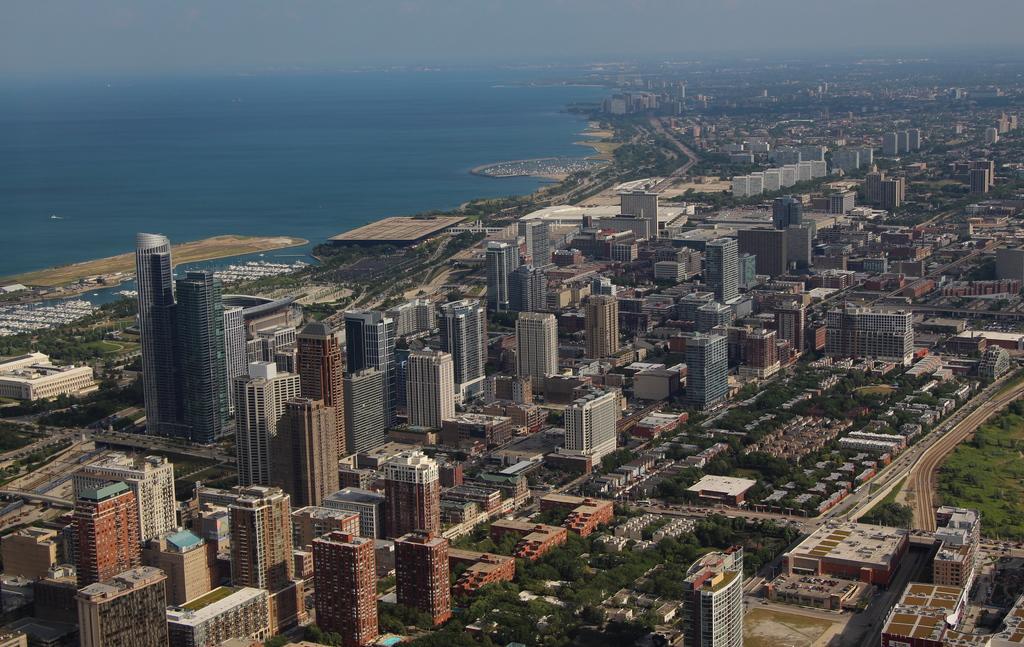How would you summarize this image in a sentence or two? This is an overview of a city where we can see buildings, trees and a surface of water. 